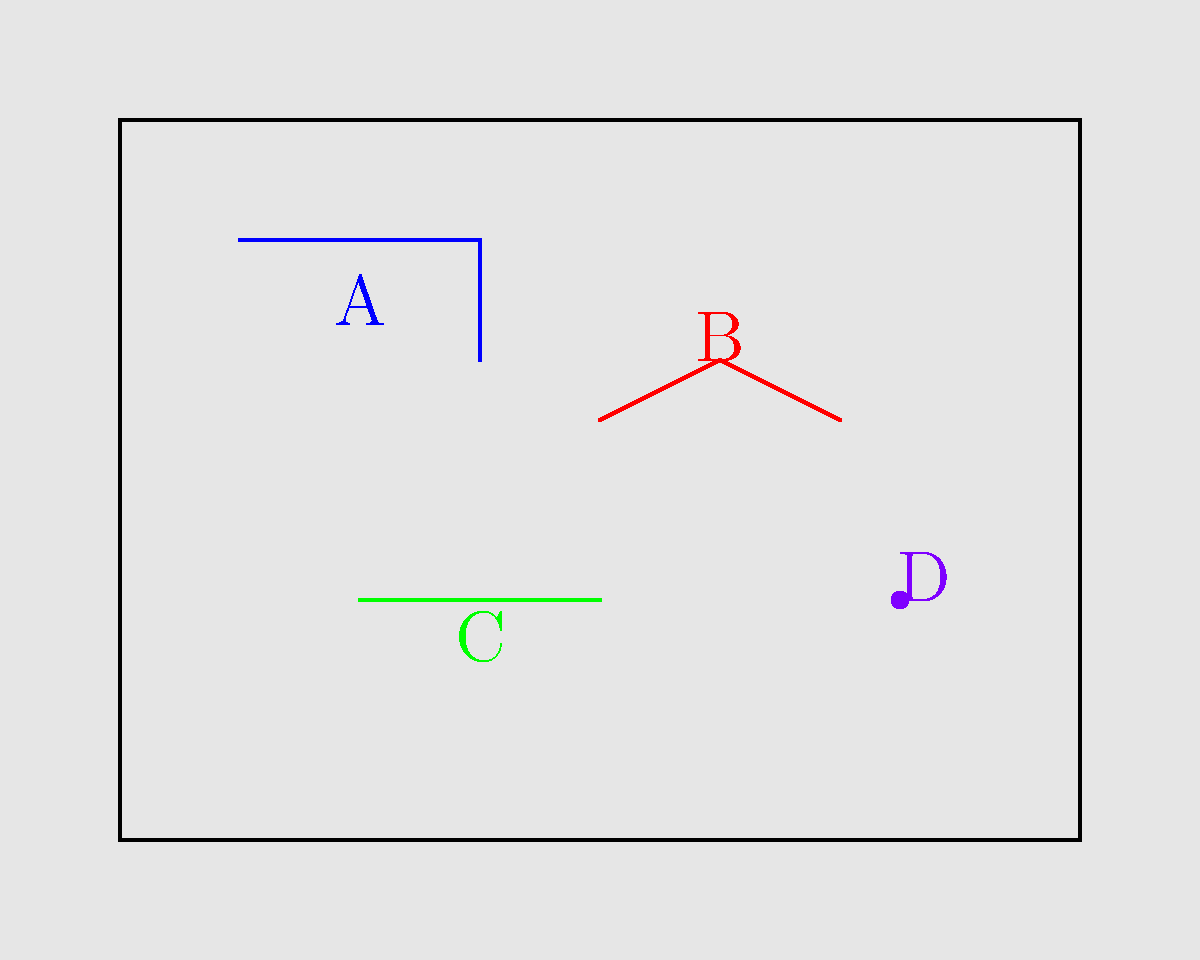In the illustration of an abandoned building, five potential hazards are labeled A through E. Which of these hazards poses the greatest risk of electrical injury? To identify the hazard with the greatest risk of electrical injury, let's analyze each labeled item:

1. A (Blue): This appears to be a broken window. While it poses a cut hazard, it's not associated with electrical injuries.

2. B (Red): These are exposed wires. Exposed electrical wiring presents a significant risk of electric shock or electrocution, especially if the wires are still live.

3. C (Green): This seems to be an unstable floorboard. It's a tripping hazard but not an electrical danger.

4. D (Purple): This is likely a rusty nail. It presents a puncture or tetanus risk, but not an electrical hazard.

5. E (Olive): This appears to be mold. While mold can cause health issues, it's not related to electrical injuries.

Among these hazards, only the exposed wires (B) are directly related to electrical systems and pose a risk of electrical injury. The others, while dangerous in their own ways, do not present an electrical hazard.
Answer: B (exposed wires) 